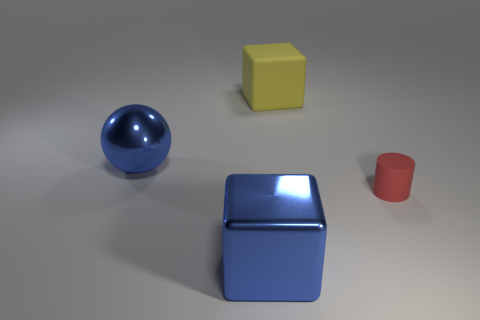Are there any other things that are the same material as the yellow block?
Your answer should be compact. Yes. There is a rubber thing right of the large block right of the blue metallic block; what number of red objects are left of it?
Offer a terse response. 0. What is the size of the yellow cube?
Ensure brevity in your answer.  Large. Do the ball and the large shiny block have the same color?
Offer a terse response. Yes. What is the size of the rubber thing in front of the blue metal sphere?
Ensure brevity in your answer.  Small. There is a large cube in front of the big yellow cube; is its color the same as the large metallic thing that is behind the small red matte object?
Offer a terse response. Yes. How many other objects are the same shape as the large yellow rubber object?
Make the answer very short. 1. Is the number of things in front of the big blue ball the same as the number of matte objects that are behind the small red cylinder?
Your answer should be compact. No. Are the large cube in front of the big blue sphere and the blue sphere that is in front of the yellow thing made of the same material?
Give a very brief answer. Yes. What number of other objects are the same size as the red object?
Offer a terse response. 0. 